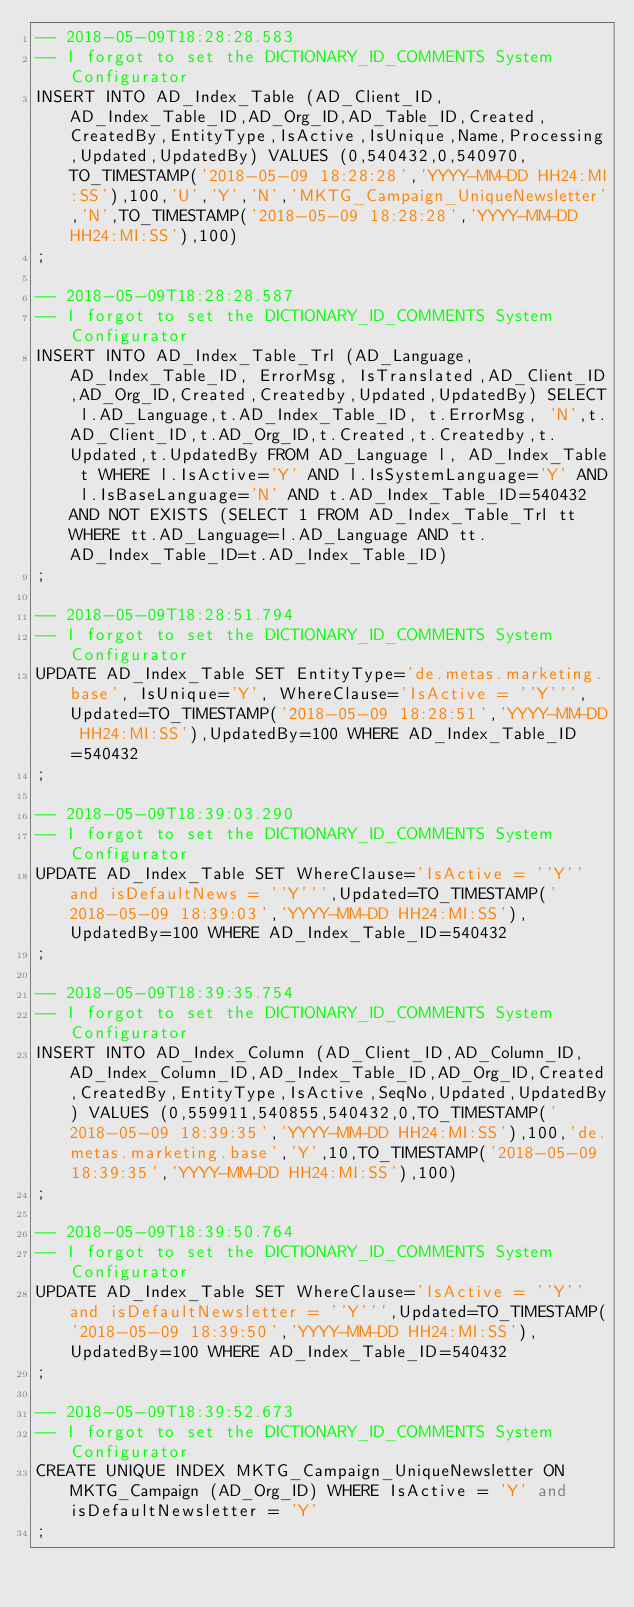Convert code to text. <code><loc_0><loc_0><loc_500><loc_500><_SQL_>-- 2018-05-09T18:28:28.583
-- I forgot to set the DICTIONARY_ID_COMMENTS System Configurator
INSERT INTO AD_Index_Table (AD_Client_ID,AD_Index_Table_ID,AD_Org_ID,AD_Table_ID,Created,CreatedBy,EntityType,IsActive,IsUnique,Name,Processing,Updated,UpdatedBy) VALUES (0,540432,0,540970,TO_TIMESTAMP('2018-05-09 18:28:28','YYYY-MM-DD HH24:MI:SS'),100,'U','Y','N','MKTG_Campaign_UniqueNewsletter','N',TO_TIMESTAMP('2018-05-09 18:28:28','YYYY-MM-DD HH24:MI:SS'),100)
;

-- 2018-05-09T18:28:28.587
-- I forgot to set the DICTIONARY_ID_COMMENTS System Configurator
INSERT INTO AD_Index_Table_Trl (AD_Language,AD_Index_Table_ID, ErrorMsg, IsTranslated,AD_Client_ID,AD_Org_ID,Created,Createdby,Updated,UpdatedBy) SELECT l.AD_Language,t.AD_Index_Table_ID, t.ErrorMsg, 'N',t.AD_Client_ID,t.AD_Org_ID,t.Created,t.Createdby,t.Updated,t.UpdatedBy FROM AD_Language l, AD_Index_Table t WHERE l.IsActive='Y' AND l.IsSystemLanguage='Y' AND l.IsBaseLanguage='N' AND t.AD_Index_Table_ID=540432 AND NOT EXISTS (SELECT 1 FROM AD_Index_Table_Trl tt WHERE tt.AD_Language=l.AD_Language AND tt.AD_Index_Table_ID=t.AD_Index_Table_ID)
;

-- 2018-05-09T18:28:51.794
-- I forgot to set the DICTIONARY_ID_COMMENTS System Configurator
UPDATE AD_Index_Table SET EntityType='de.metas.marketing.base', IsUnique='Y', WhereClause='IsActive = ''Y''',Updated=TO_TIMESTAMP('2018-05-09 18:28:51','YYYY-MM-DD HH24:MI:SS'),UpdatedBy=100 WHERE AD_Index_Table_ID=540432
;

-- 2018-05-09T18:39:03.290
-- I forgot to set the DICTIONARY_ID_COMMENTS System Configurator
UPDATE AD_Index_Table SET WhereClause='IsActive = ''Y'' and isDefaultNews = ''Y''',Updated=TO_TIMESTAMP('2018-05-09 18:39:03','YYYY-MM-DD HH24:MI:SS'),UpdatedBy=100 WHERE AD_Index_Table_ID=540432
;

-- 2018-05-09T18:39:35.754
-- I forgot to set the DICTIONARY_ID_COMMENTS System Configurator
INSERT INTO AD_Index_Column (AD_Client_ID,AD_Column_ID,AD_Index_Column_ID,AD_Index_Table_ID,AD_Org_ID,Created,CreatedBy,EntityType,IsActive,SeqNo,Updated,UpdatedBy) VALUES (0,559911,540855,540432,0,TO_TIMESTAMP('2018-05-09 18:39:35','YYYY-MM-DD HH24:MI:SS'),100,'de.metas.marketing.base','Y',10,TO_TIMESTAMP('2018-05-09 18:39:35','YYYY-MM-DD HH24:MI:SS'),100)
;

-- 2018-05-09T18:39:50.764
-- I forgot to set the DICTIONARY_ID_COMMENTS System Configurator
UPDATE AD_Index_Table SET WhereClause='IsActive = ''Y'' and isDefaultNewsletter = ''Y''',Updated=TO_TIMESTAMP('2018-05-09 18:39:50','YYYY-MM-DD HH24:MI:SS'),UpdatedBy=100 WHERE AD_Index_Table_ID=540432
;

-- 2018-05-09T18:39:52.673
-- I forgot to set the DICTIONARY_ID_COMMENTS System Configurator
CREATE UNIQUE INDEX MKTG_Campaign_UniqueNewsletter ON MKTG_Campaign (AD_Org_ID) WHERE IsActive = 'Y' and isDefaultNewsletter = 'Y'
;
</code> 